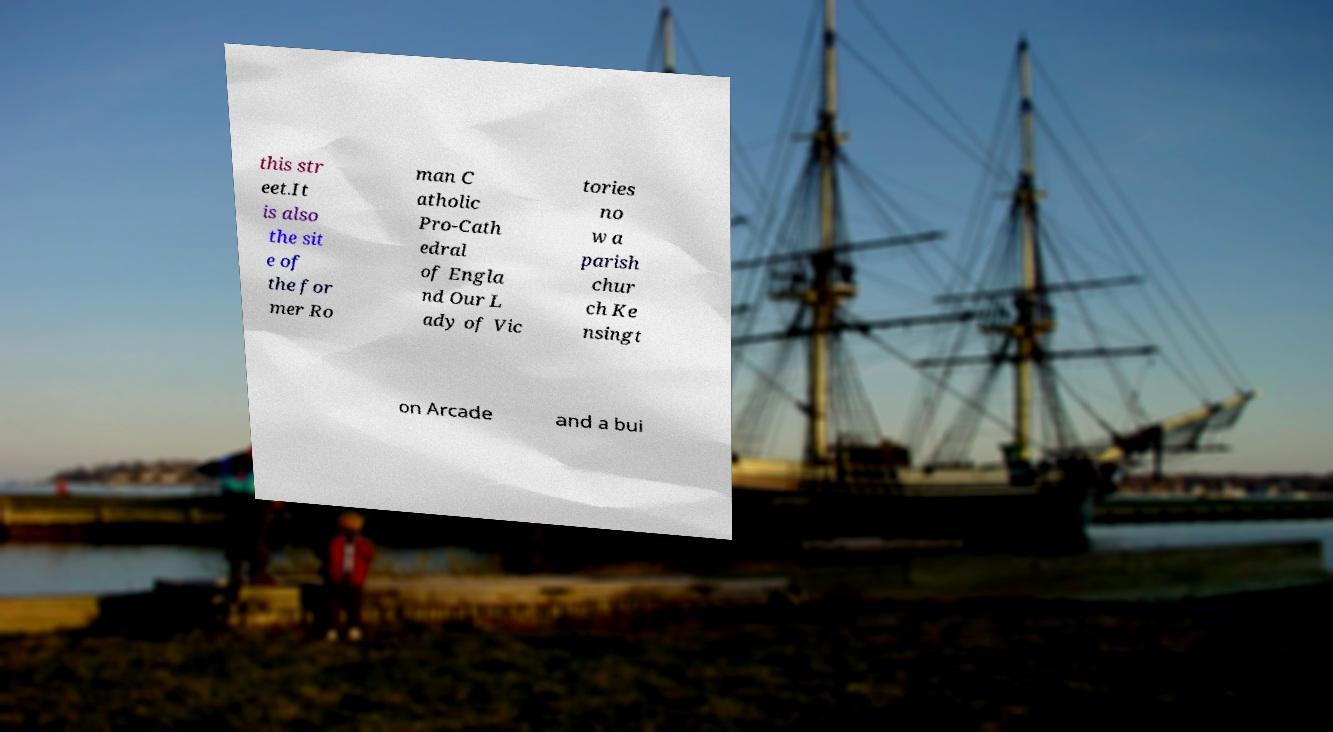What messages or text are displayed in this image? I need them in a readable, typed format. this str eet.It is also the sit e of the for mer Ro man C atholic Pro-Cath edral of Engla nd Our L ady of Vic tories no w a parish chur ch Ke nsingt on Arcade and a bui 